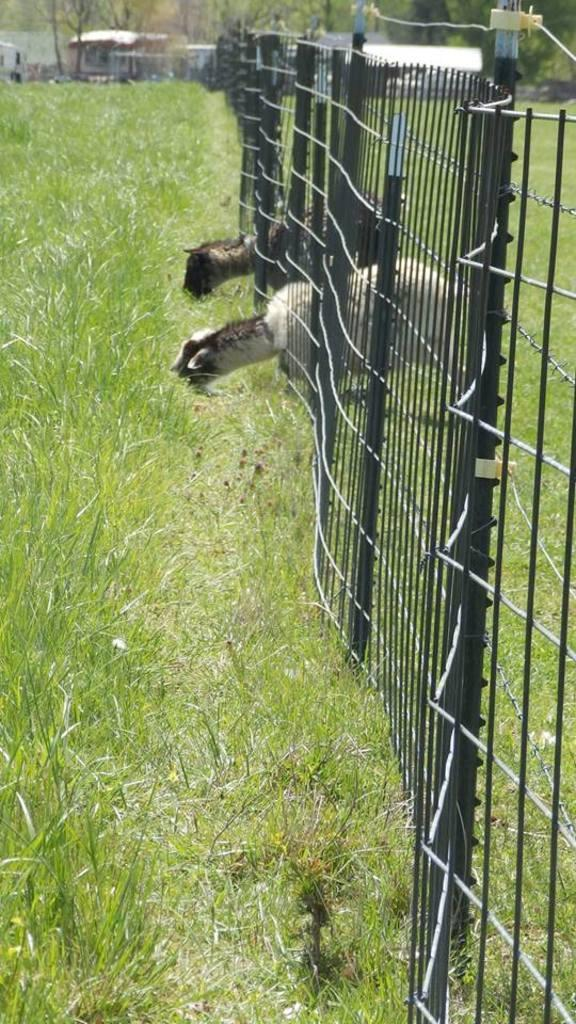How many animals are present in the image? There are two animals in the image. What are the animals doing in the image? The animals are eating grass. What can be seen on the right side of the image? There is fencing on the right side of the image. What is visible in the background of the image? There are houses and trees in the background of the image. How many people are in the crowd in the image? There is no crowd present in the image; it features two animals eating grass and a background with houses and trees. 